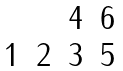<formula> <loc_0><loc_0><loc_500><loc_500>\begin{matrix} & & 4 & 6 \\ 1 & 2 & 3 & 5 \\ \end{matrix}</formula> 